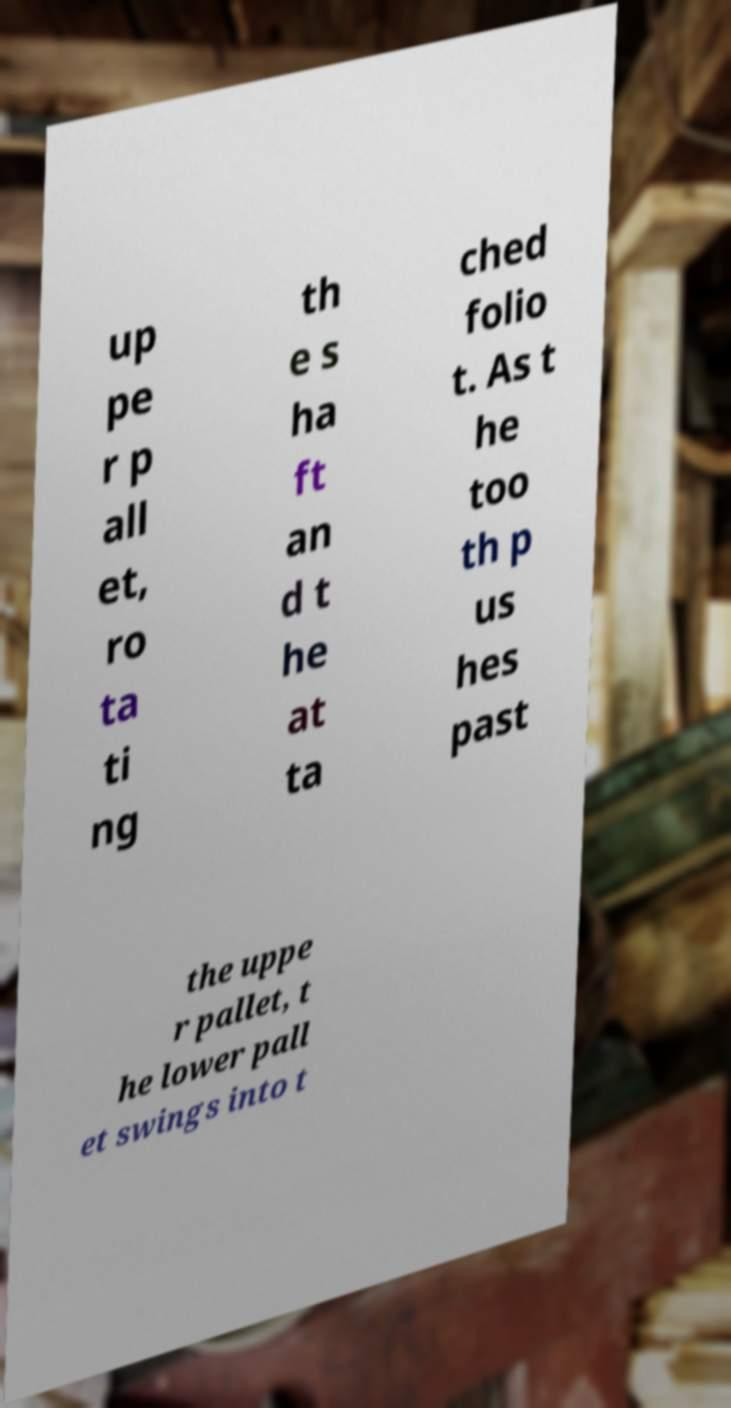What messages or text are displayed in this image? I need them in a readable, typed format. up pe r p all et, ro ta ti ng th e s ha ft an d t he at ta ched folio t. As t he too th p us hes past the uppe r pallet, t he lower pall et swings into t 